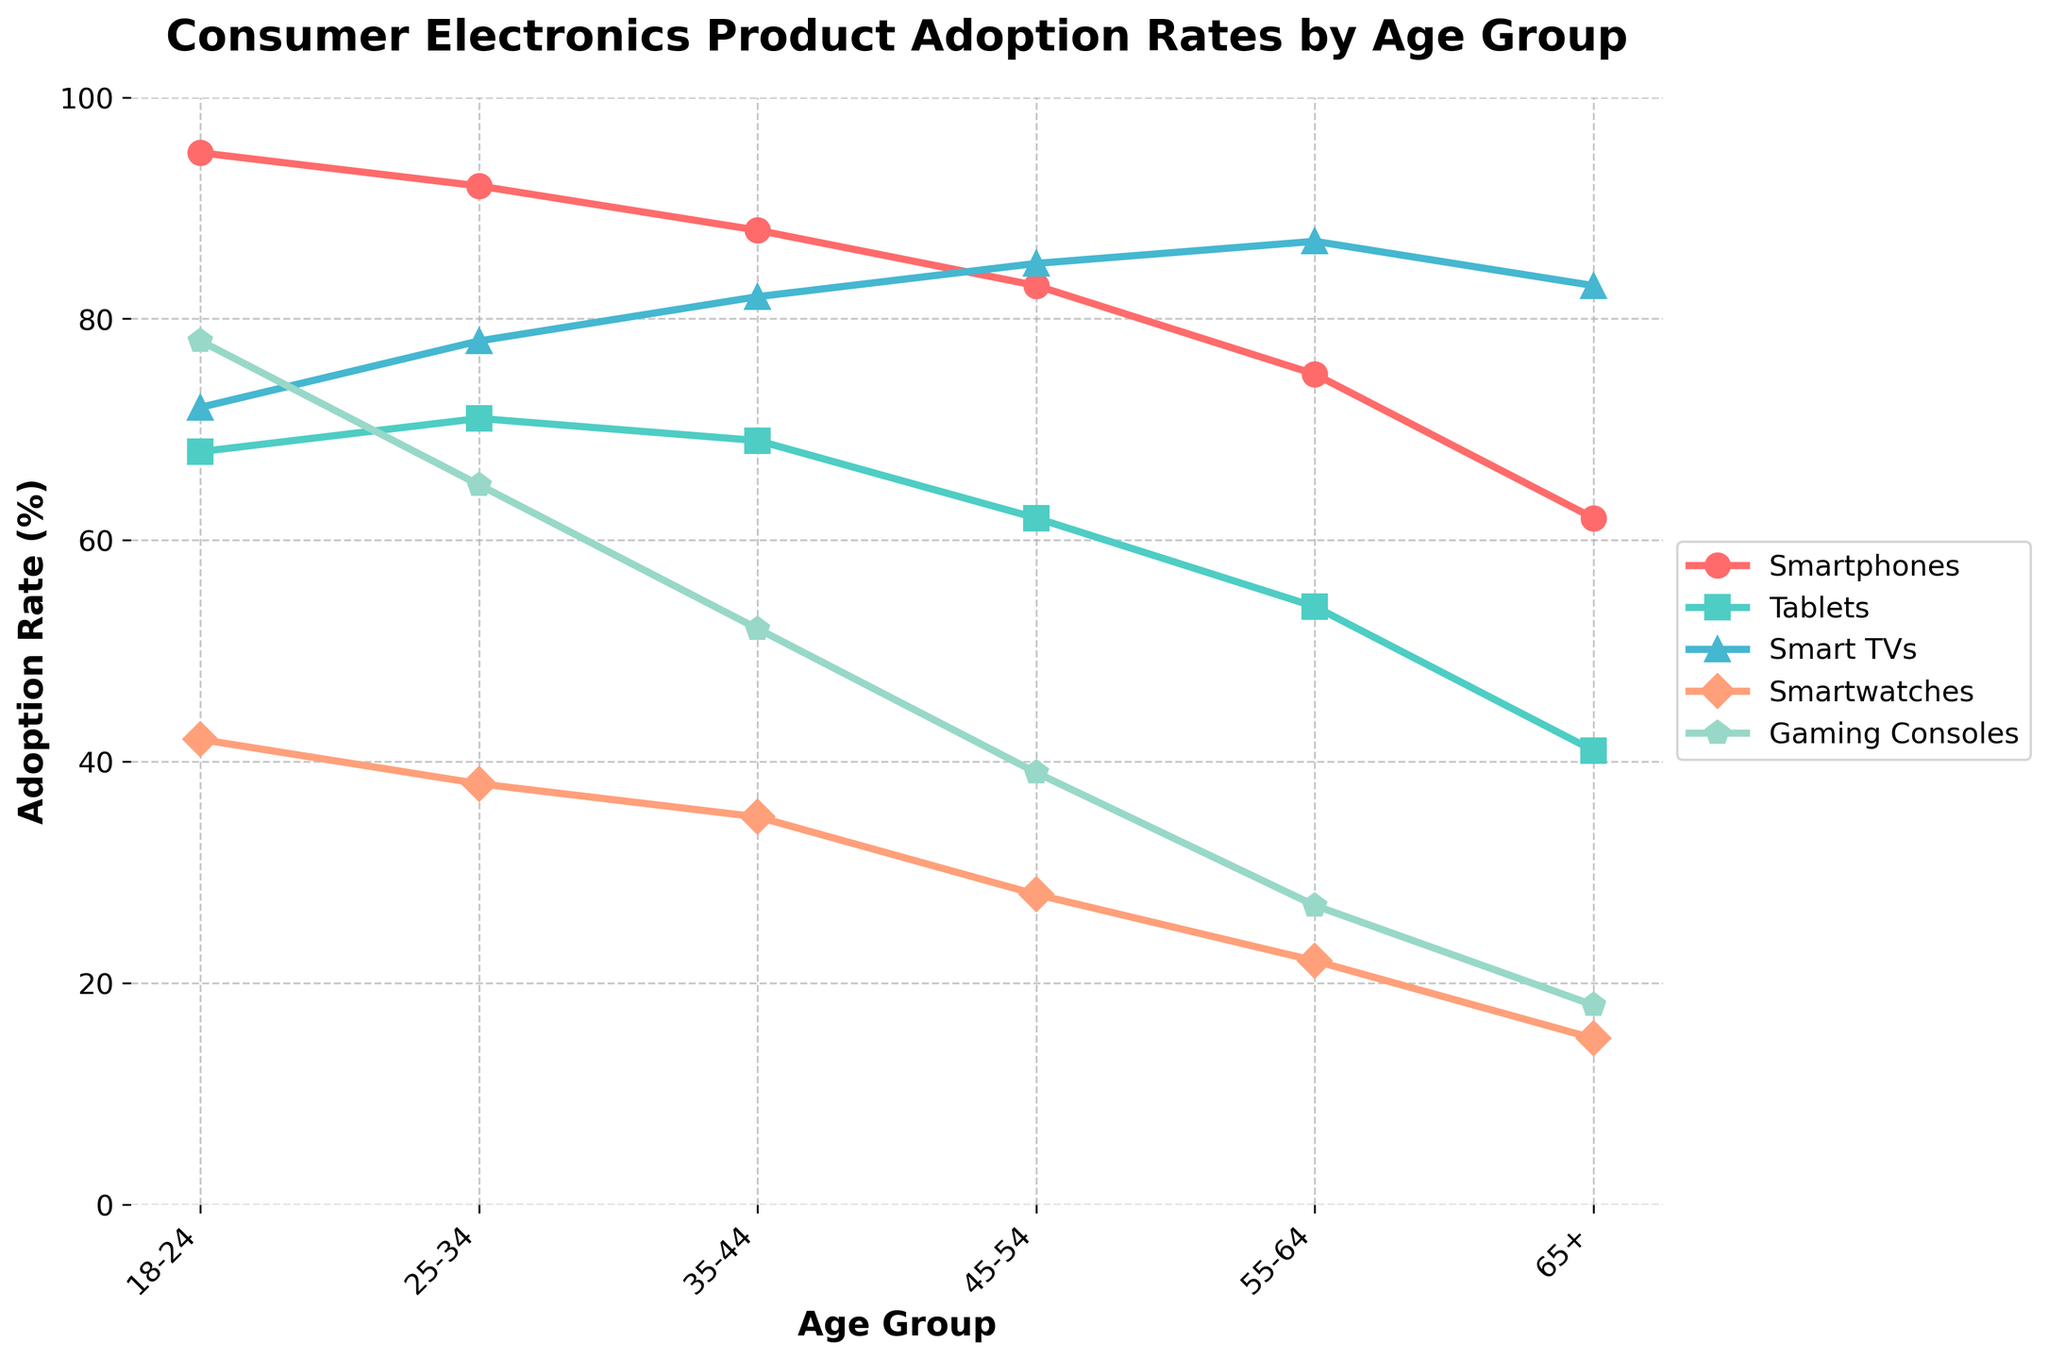What age group has the highest adoption rate for Smart TVs? Looking at the graph, the highest point for Smart TVs (colored line) corresponds to the age group 55-64.
Answer: 55-64 Which product has the lowest adoption rate among 18-24 age group? Checking the plot for the 18-24 category, Smartwatches have the lowest adoption rate.
Answer: Smartwatches What is the difference in the adoption rate of Gaming Consoles between the age groups 18-24 and 35-44? The adoption rate for Gaming Consoles in the 18-24 age group is 78%, and for 35-44 it is 52%. The difference is 78 - 52 = 26%.
Answer: 26% Which age group shows the most significant adoption rate decline for Smartwatches compared to the previous younger age group? The adoption of Smartwatches drops from 42% in the 18-24 group to 38% in the 25-34 group, a difference of 4%, which is the largest decline between consecutive age groups.
Answer: 18-24 to 25-34 What is the average adoption rate of Smartphones across all age groups? Summing the adoption rates for Smartphones across all age groups: 95 + 92 + 88 + 83 + 75 + 62 = 495. There are 6 age groups, so the average is 495 / 6 = 82.5%.
Answer: 82.5% How does the adoption rate for Tablets in the 25-34 age group compare to that of the 45-54 age group? The adoption rates for Tablets are 71% for the 25-34 age group and 62% for the 45-54 age group. Thus, 71% is higher than 62%.
Answer: Higher Among the 35-44 age group, which product has the second highest adoption rate? Within the 35-44 age group, the two highest adoption rates are Smart TVs (82%) and Smartphones (88%). Therefore, the second highest is Smart TVs.
Answer: Smart TVs What is the combined adoption rate of Smart TVs and Smartwatches for the 65+ age group? The adoption rates for Smart TVs and Smartwatches in the 65+ age group are 83% and 15%, respectively. Combined, 83 + 15 = 98%.
Answer: 98% Which product consistently shows a decrease in adoption rate as the age group increases? By examining all product lines across age groups, it is apparent that the adoption rate of Smartphones consistently decreases as age increases.
Answer: Smartphones How does the adoption rate for Smartwatches in the 25-34 group compare to that in the 55-64 group? The adoption rates for Smartwatches are 38% for the 25-34 age group and 22% for the 55-64 age group. Thus, 38% is higher than 22%.
Answer: Higher 